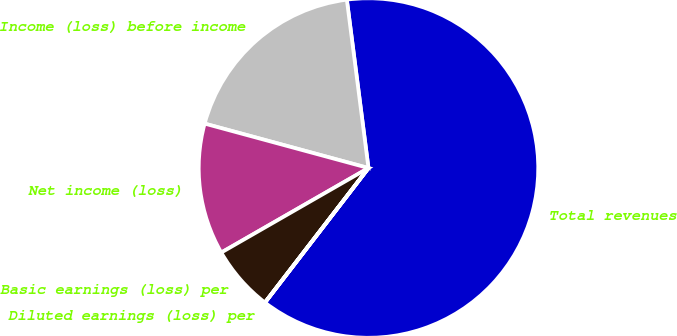<chart> <loc_0><loc_0><loc_500><loc_500><pie_chart><fcel>Total revenues<fcel>Income (loss) before income<fcel>Net income (loss)<fcel>Basic earnings (loss) per<fcel>Diluted earnings (loss) per<nl><fcel>62.47%<fcel>18.75%<fcel>12.51%<fcel>6.26%<fcel>0.01%<nl></chart> 